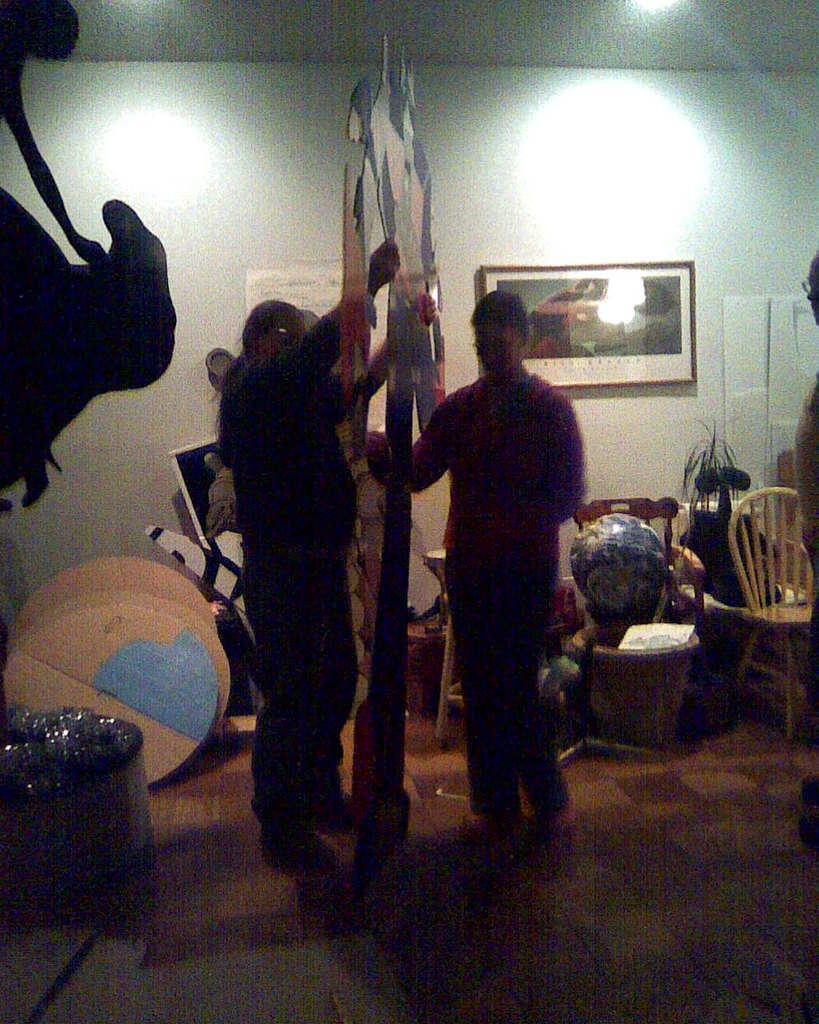Please provide a concise description of this image. In this image we can see a group of people standing on the floor. One person is holding an object in his hands. On the left side of the image we can see some boards placed and some objects placed on the floor. In the right side of the image we can see a ball placed on the chair, we can also a plant. In the background of the image we can see some photo frames on the wall and a poster with some text. At the top of the image we can see the lights. 